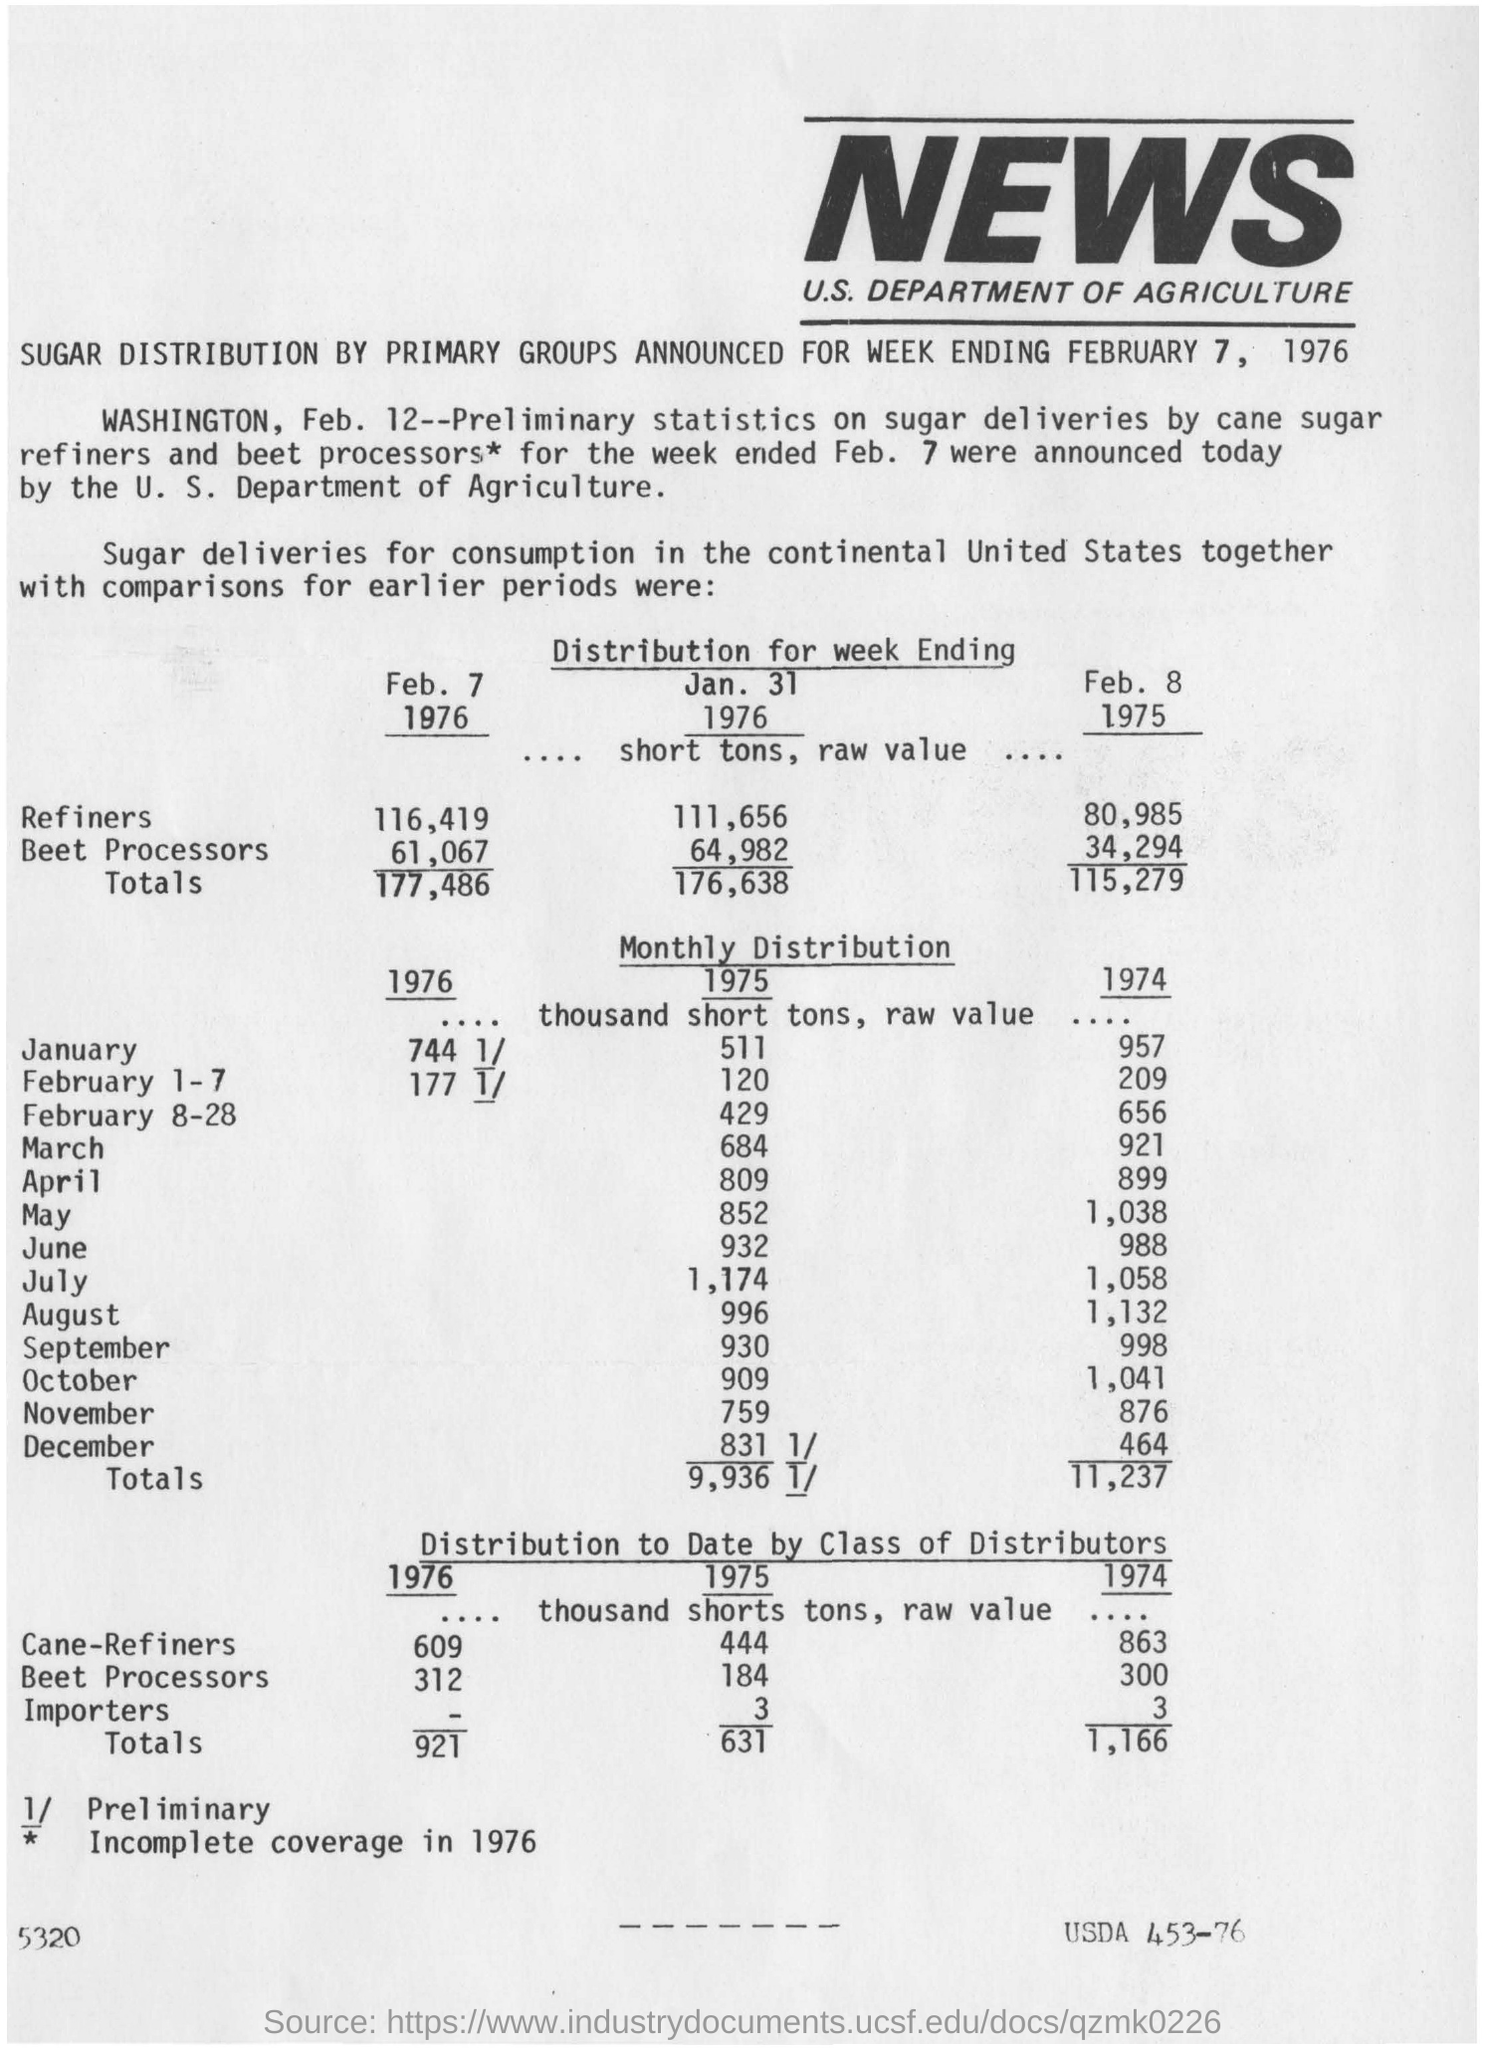List a handful of essential elements in this visual. The article discusses the distribution of sugar. What is the value corresponding to importers for the year 1975?" is a question that is seeking information. This news coverage is related to the U.S. Department of Agriculture. 